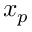Convert formula to latex. <formula><loc_0><loc_0><loc_500><loc_500>x _ { p }</formula> 